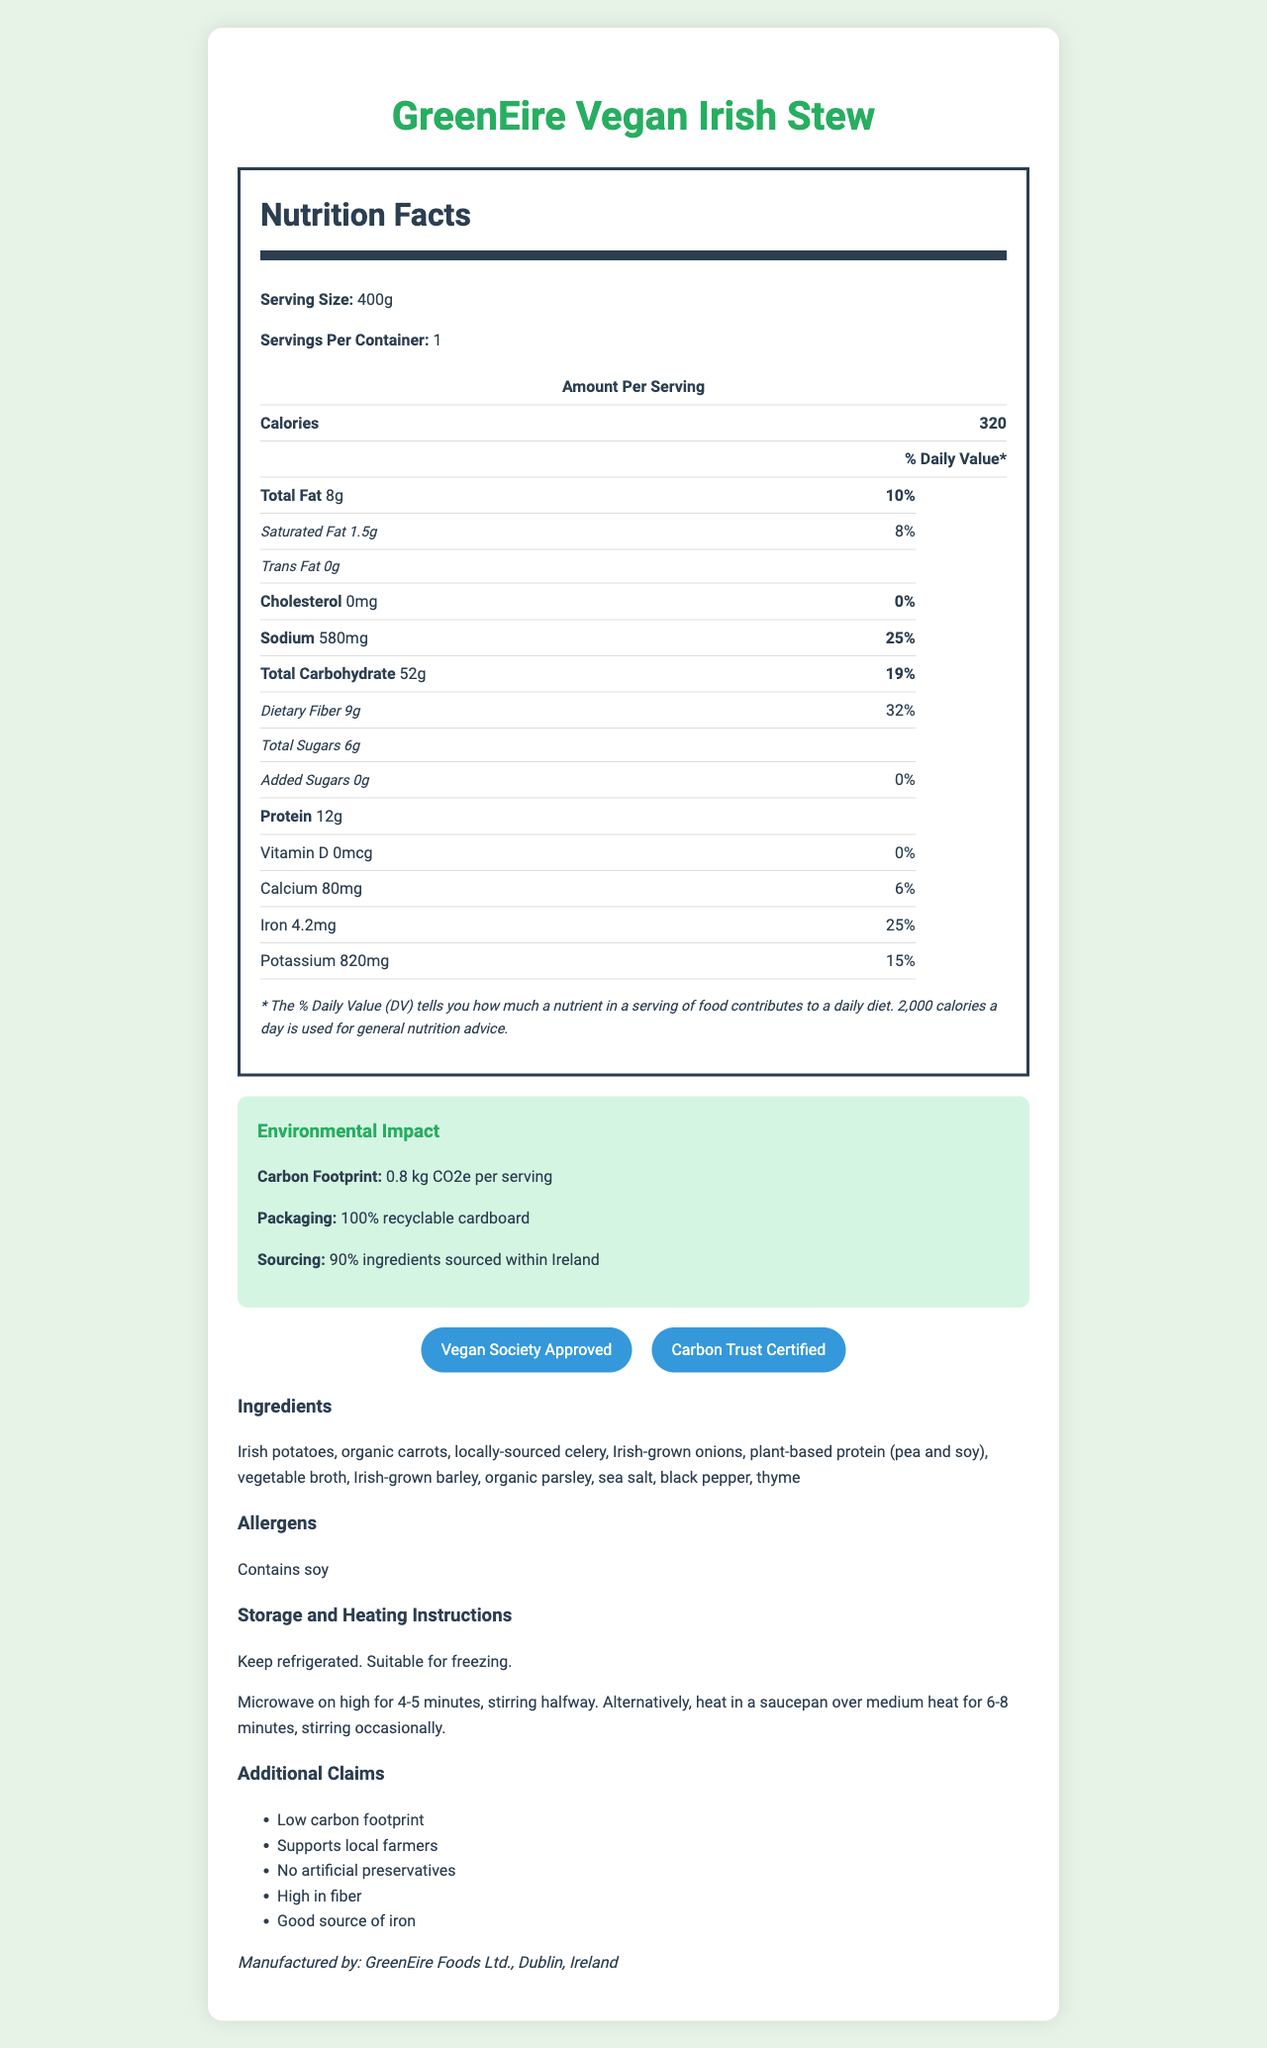What is the serving size of the GreenEire Vegan Irish Stew? The document states that the serving size is 400g.
Answer: 400g How many calories are in one serving of the GreenEire Vegan Irish Stew? According to the document, there are 320 calories per serving.
Answer: 320 What percentage of the daily value of iron does one serving provide? The document indicates that one serving provides 25% of the daily value of iron.
Answer: 25% Which allergen is present in the GreenEire Vegan Irish Stew? The document lists soy as the allergen contained in the product.
Answer: Soy What is the carbon footprint per serving of the GreenEire Vegan Irish Stew? The environmental section states the carbon footprint is 0.8 kg CO2e per serving.
Answer: 0.8 kg CO2e per serving What is the total fat content per serving? A. 6g B. 7g C. 8g D. 9g The document specifies that the total fat content per serving is 8g.
Answer: C. 8g What type of packaging does the GreenEire Vegan Irish Stew use? A. Non-recyclable B. Recyclable plastic C. 100% recyclable cardboard The environmental impact section mentions that the packaging is 100% recyclable cardboard.
Answer: C. 100% recyclable cardboard Does the GreenEire Vegan Irish Stew contain any added sugars? The document states that there are 0g of added sugars, meaning it does not contain any.
Answer: No Is the GreenEire Vegan Irish Stew suitable for freezing? The storage instructions clearly state that the stew is suitable for freezing.
Answer: Yes Summarize the main points of the GreenEire Vegan Irish Stew document. This summary captures the key details and the significant claims mentioned in the document about the product, its nutritional content, environmental impact, and certifications.
Answer: The GreenEire Vegan Irish Stew is a ready-meal product emphasizing its low carbon footprint and local sourcing. It provides detailed nutritional information, including 320 calories per 400g serving, 8g of total fat, and 12g of protein. The stew is rich in fiber and iron, contains no cholesterol or trans fats, and uses 100% recyclable cardboard packaging. It supports local farmers, is free from artificial preservatives, and has several environmental and vegan certifications. How many ingredients are certified organic in the GreenEire Vegan Irish Stew? The document only states that carrots are organic but does not provide clarity on any other ingredients' organic certification.
Answer: Not enough information What is the method for heating the stew in a microwave? The heating instructions specify microwave on high for 4-5 minutes, stirring halfway through.
Answer: Microwave on high for 4-5 minutes, stirring halfway. 